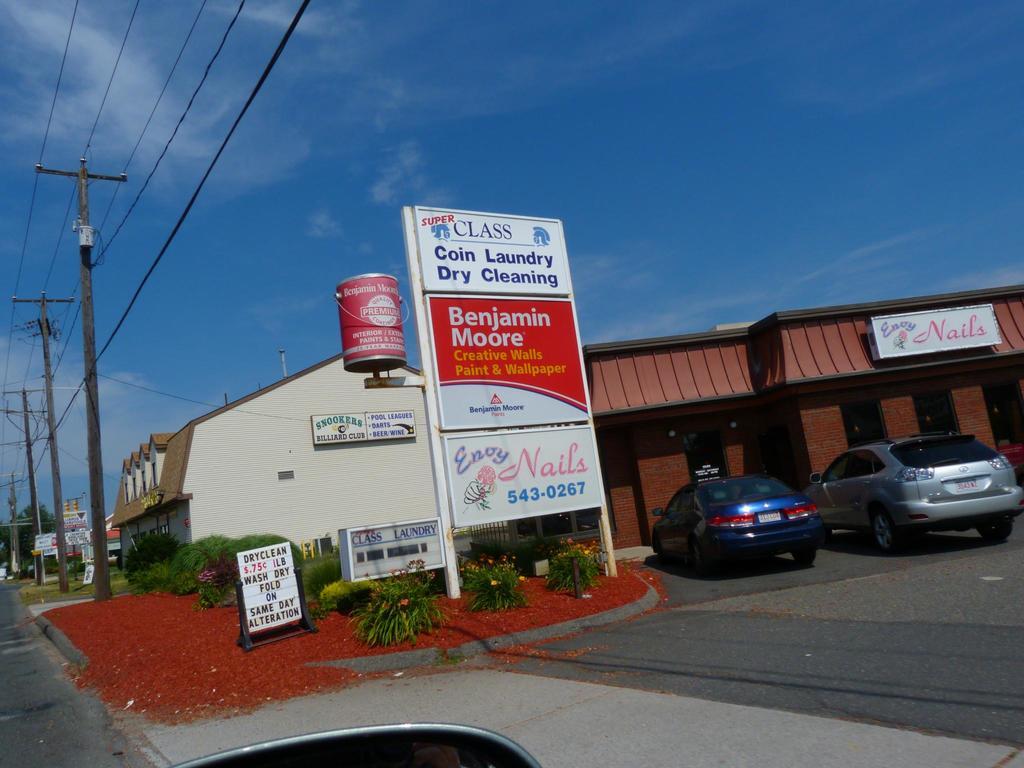What is the phone number of the nail salon?
Your response must be concise. 543-0267. What name is on the red portion of the front sign?
Your answer should be very brief. Benjamin moore. 